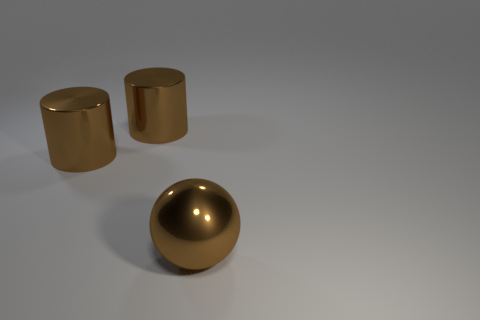Are there more large brown metal cylinders than shiny things?
Offer a very short reply. No. What number of large shiny cylinders have the same color as the sphere?
Offer a very short reply. 2. The ball is what size?
Provide a succinct answer. Large. There is a brown ball; how many brown things are on the left side of it?
Offer a terse response. 2. What number of cylinders are large objects or purple objects?
Ensure brevity in your answer.  2. What number of other things are there of the same material as the sphere
Keep it short and to the point. 2. Are there more shiny spheres to the right of the big ball than brown cylinders?
Offer a very short reply. No. What number of other things are the same color as the sphere?
Keep it short and to the point. 2. What number of metal objects are either brown spheres or tiny blocks?
Provide a succinct answer. 1. What number of things are shiny objects that are behind the big brown metal ball or big brown balls?
Give a very brief answer. 3. 